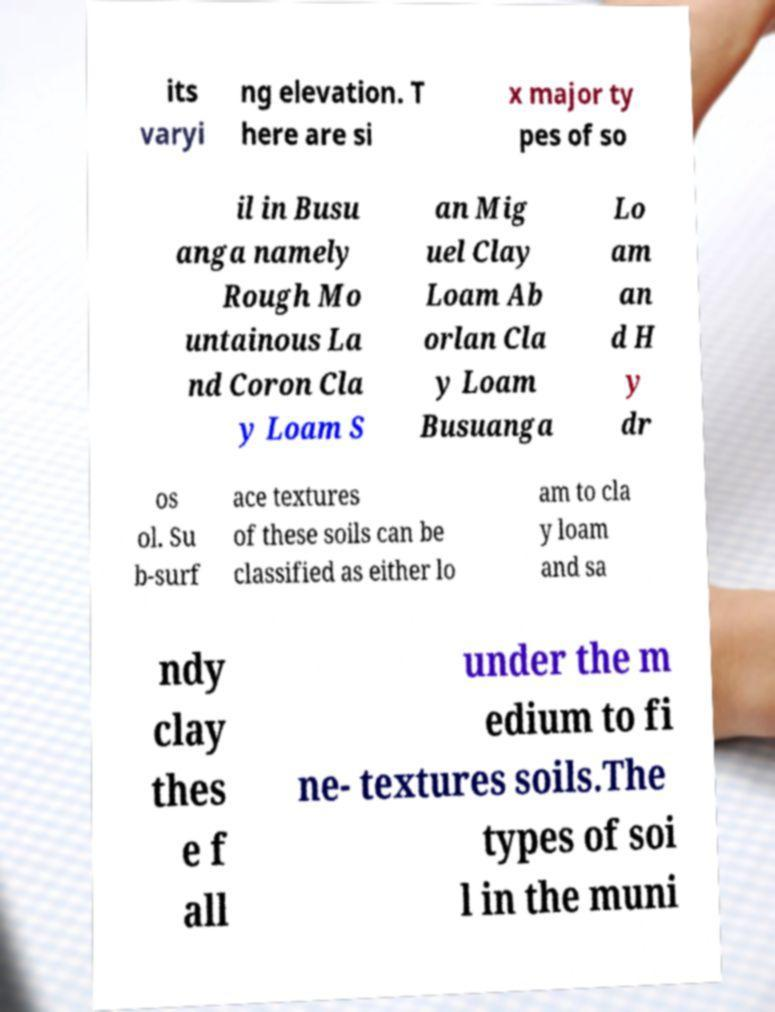Please read and relay the text visible in this image. What does it say? its varyi ng elevation. T here are si x major ty pes of so il in Busu anga namely Rough Mo untainous La nd Coron Cla y Loam S an Mig uel Clay Loam Ab orlan Cla y Loam Busuanga Lo am an d H y dr os ol. Su b-surf ace textures of these soils can be classified as either lo am to cla y loam and sa ndy clay thes e f all under the m edium to fi ne- textures soils.The types of soi l in the muni 